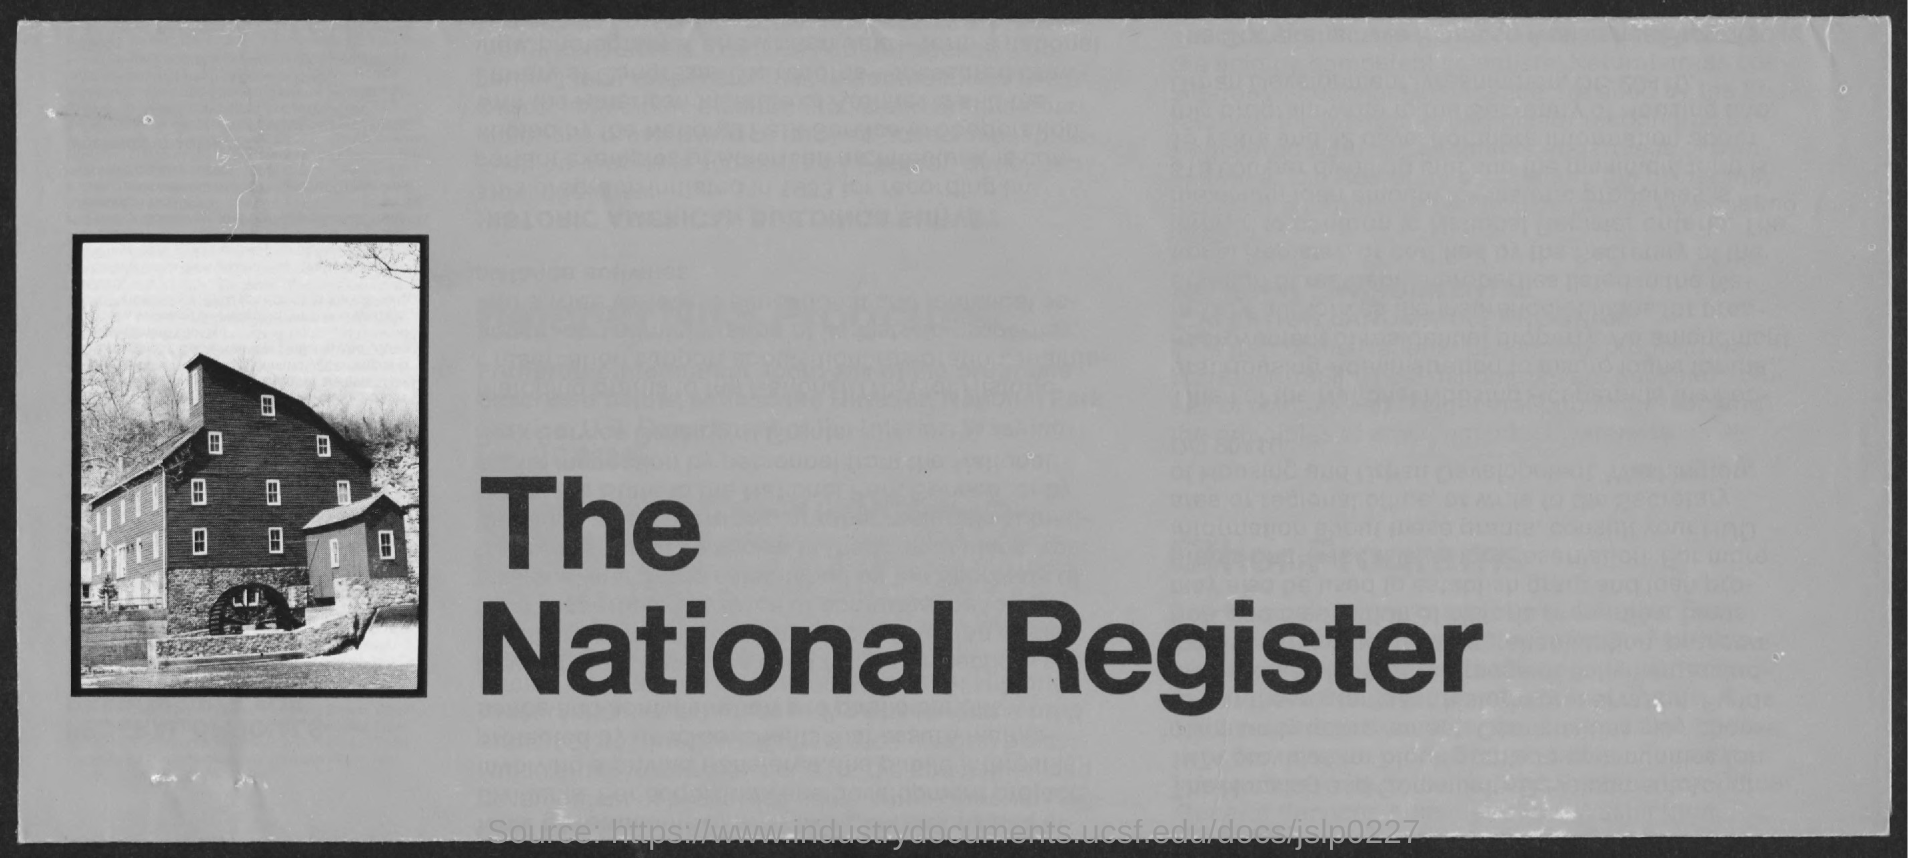What is the title of the document?
Make the answer very short. The national register. 